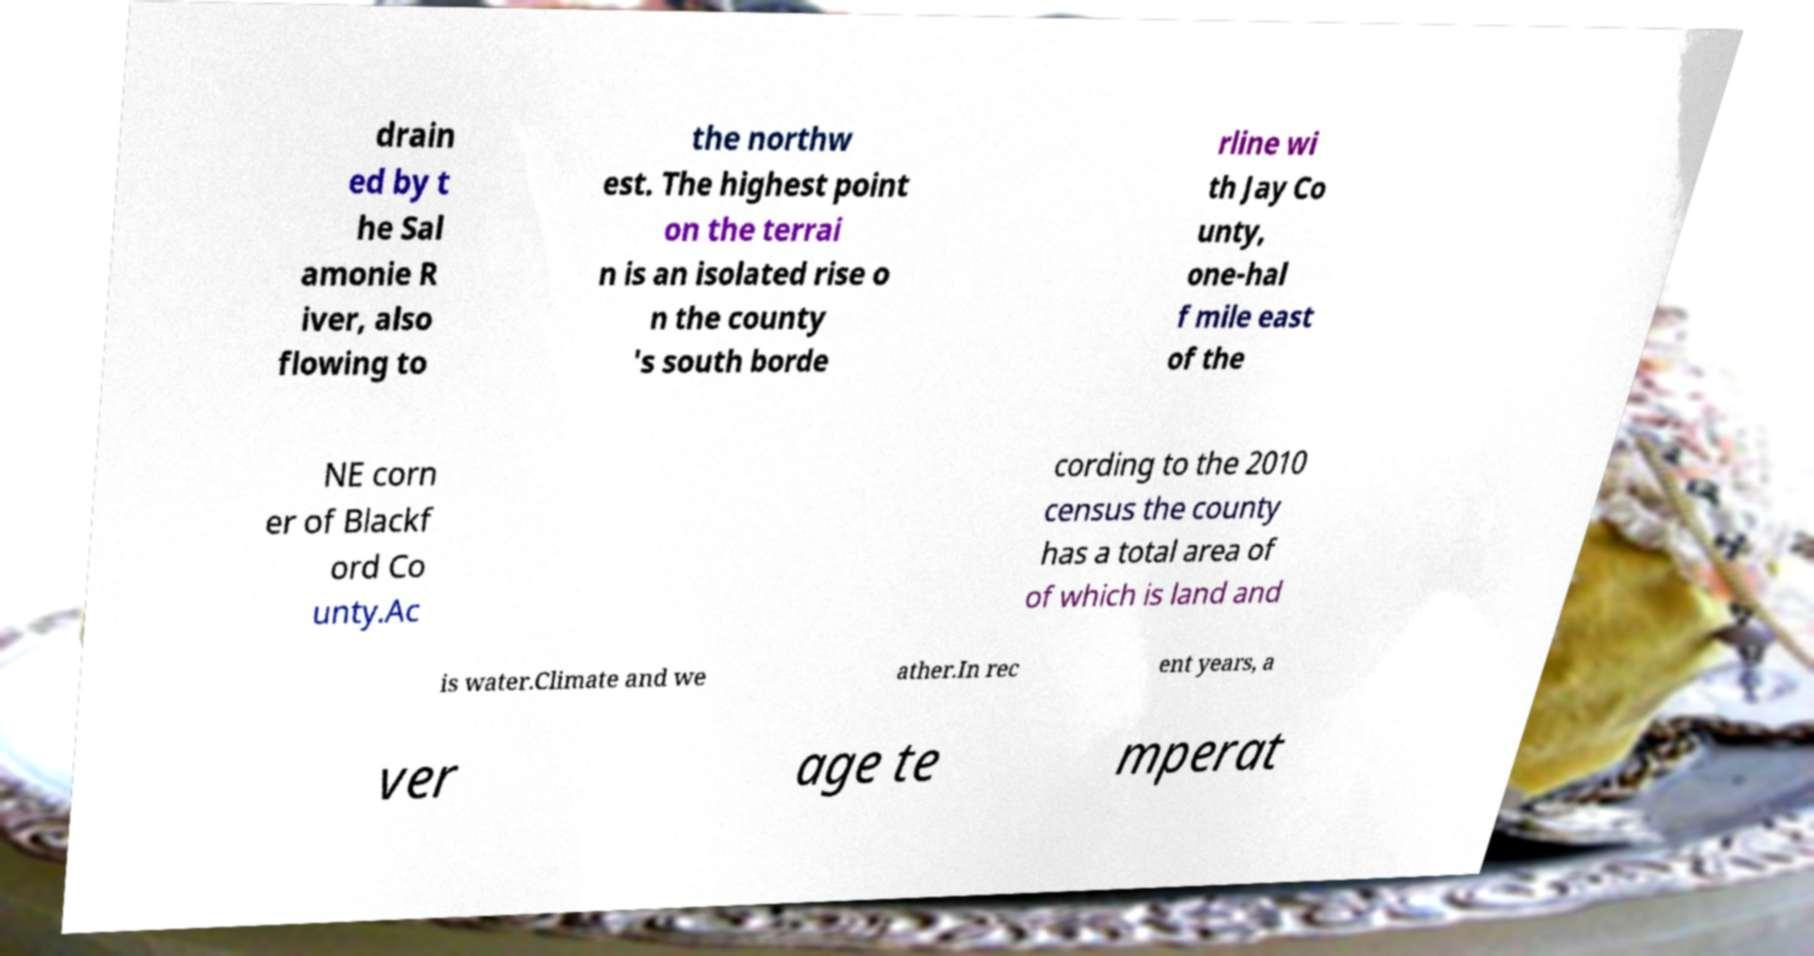What messages or text are displayed in this image? I need them in a readable, typed format. drain ed by t he Sal amonie R iver, also flowing to the northw est. The highest point on the terrai n is an isolated rise o n the county 's south borde rline wi th Jay Co unty, one-hal f mile east of the NE corn er of Blackf ord Co unty.Ac cording to the 2010 census the county has a total area of of which is land and is water.Climate and we ather.In rec ent years, a ver age te mperat 